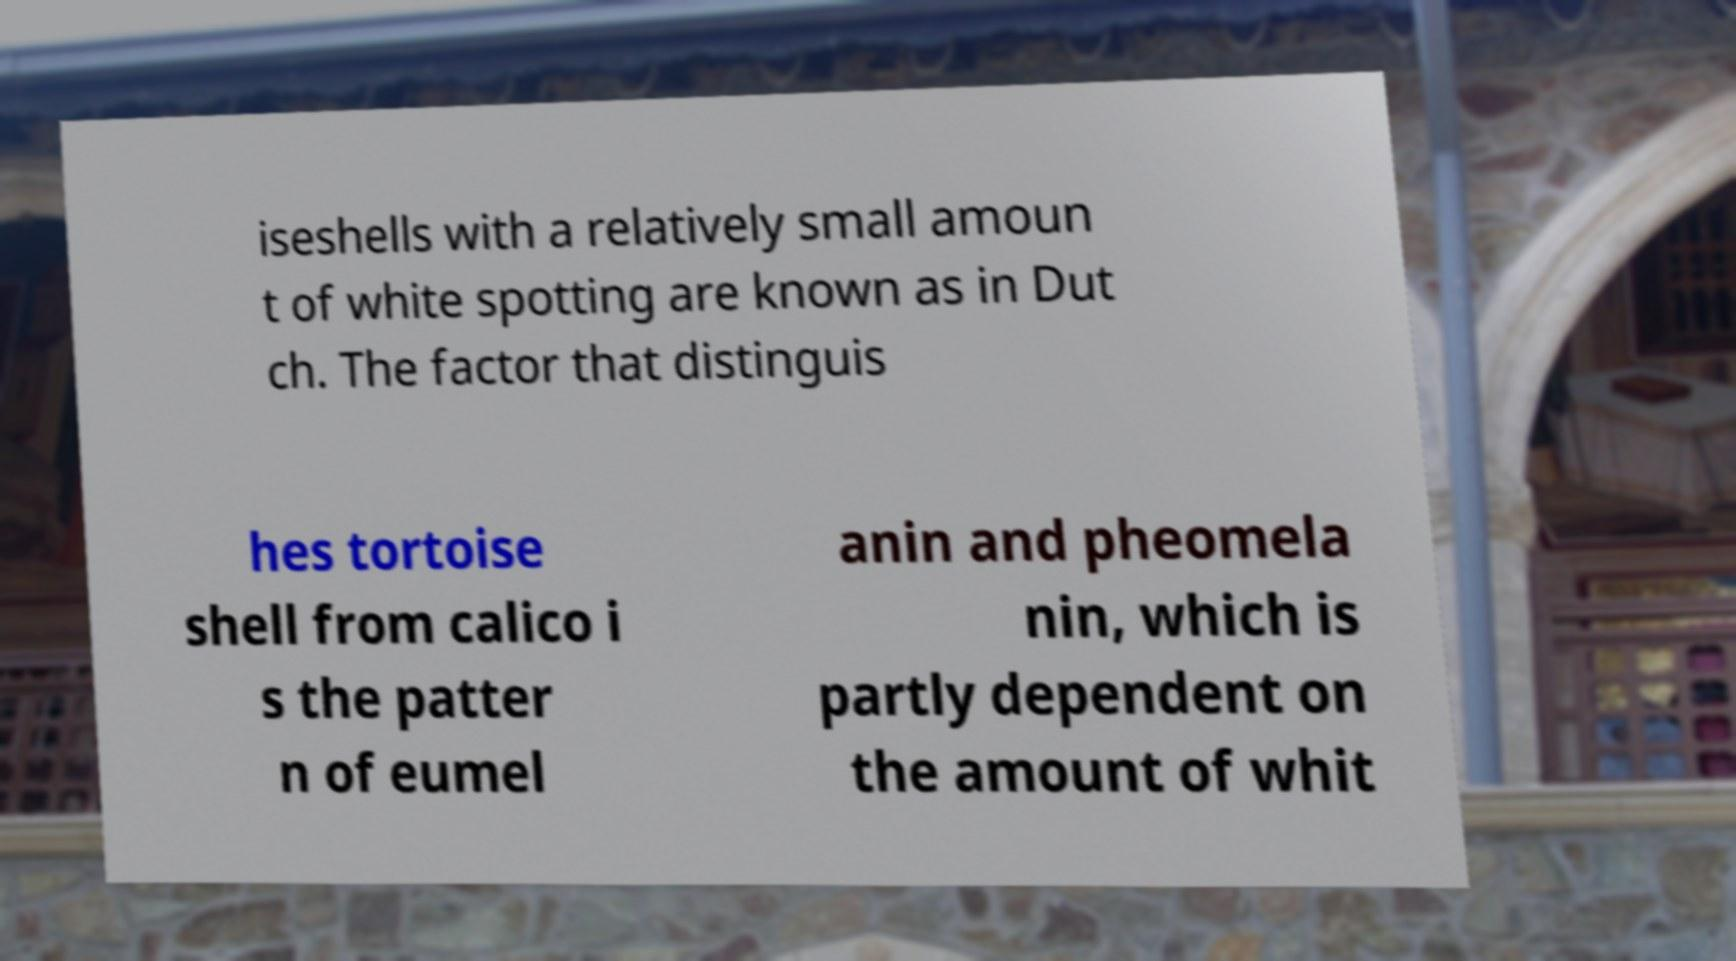What messages or text are displayed in this image? I need them in a readable, typed format. iseshells with a relatively small amoun t of white spotting are known as in Dut ch. The factor that distinguis hes tortoise shell from calico i s the patter n of eumel anin and pheomela nin, which is partly dependent on the amount of whit 